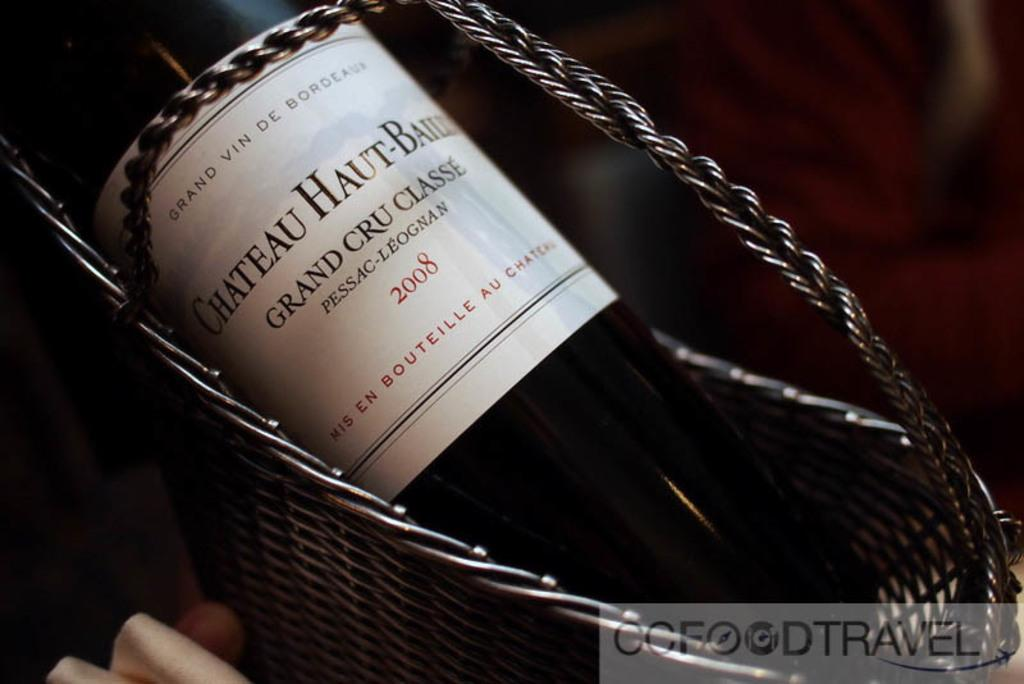<image>
Relay a brief, clear account of the picture shown. A bottle of wine with Grand Cru Classe on it. 